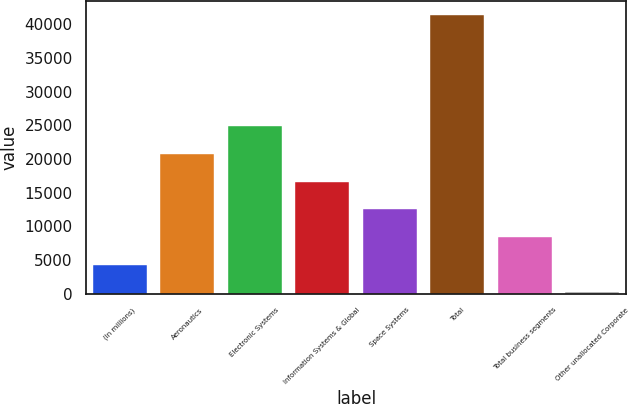<chart> <loc_0><loc_0><loc_500><loc_500><bar_chart><fcel>(In millions)<fcel>Aeronautics<fcel>Electronic Systems<fcel>Information Systems & Global<fcel>Space Systems<fcel>Total<fcel>Total business segments<fcel>Other unallocated Corporate<nl><fcel>4282.1<fcel>20766.5<fcel>24887.6<fcel>16645.4<fcel>12524.3<fcel>41372<fcel>8403.2<fcel>161<nl></chart> 